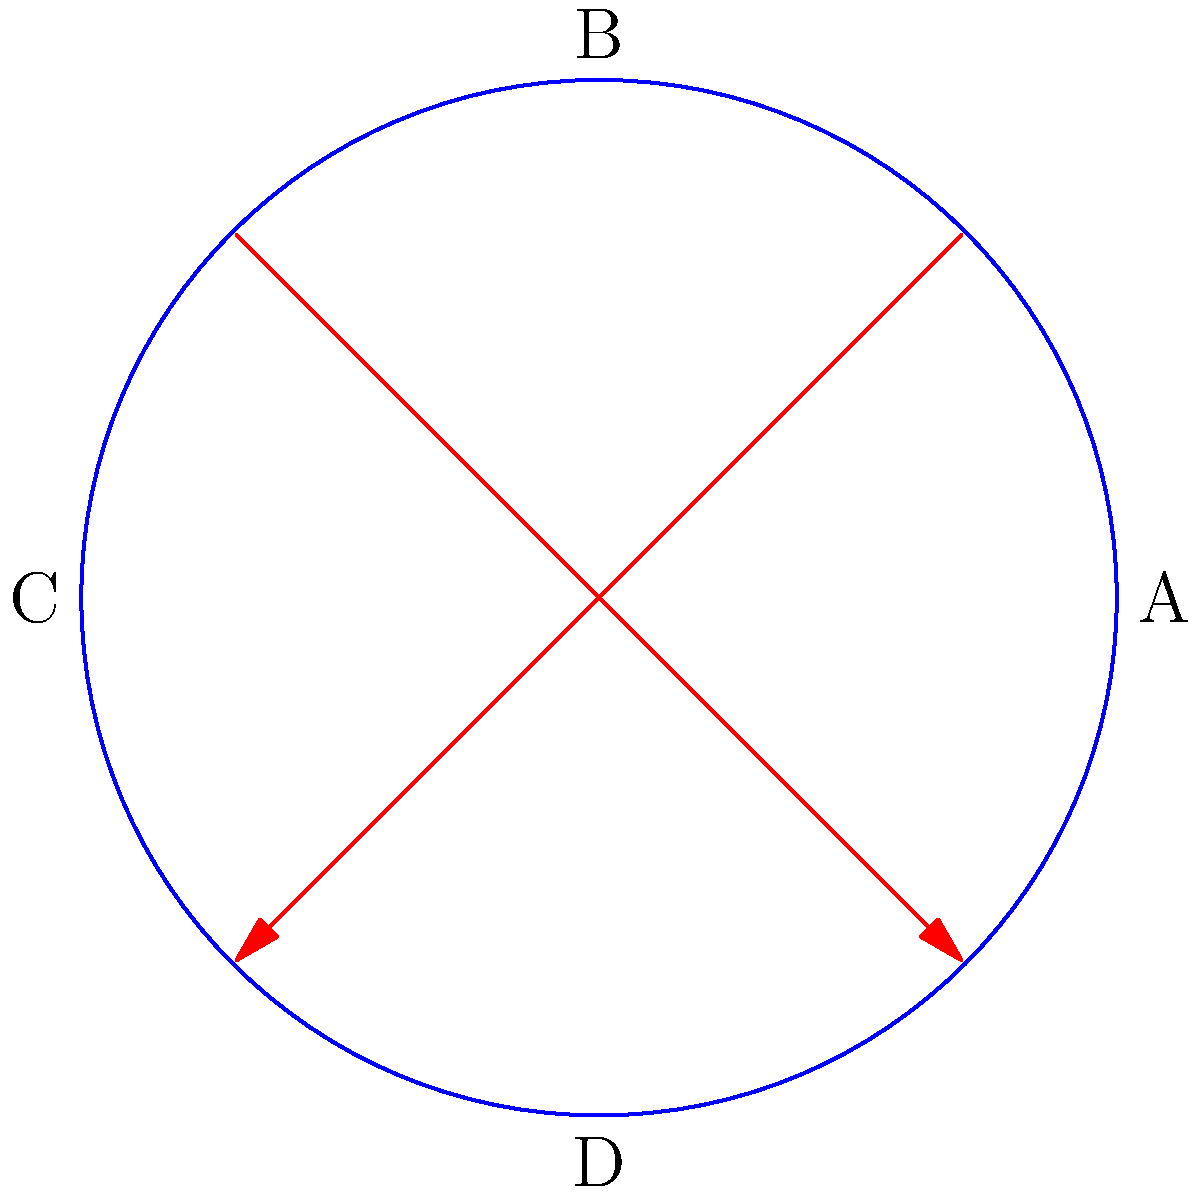As a patrol officer, you're designing a fair rotation system for four officers (A, B, C, D) across four shifts. The diagram represents a permutation in the rotation system. If this permutation is applied twice, what is the resulting arrangement of officers? Let's approach this step-by-step:

1) First, we need to understand what the diagram represents. The arrows show that:
   A swaps with C
   B swaps with D

2) This can be written in cycle notation as (AC)(BD).

3) Now, we need to apply this permutation twice. Let's see what happens:
   - Starting with ABCD
   - After first application: CBAD
   - After second application: ABCD

4) To understand why:
   - A goes to C, then C goes back to A
   - B goes to D, then D goes back to B
   - C goes to A, then A goes back to C
   - D goes to B, then B goes back to D

5) In group theory, this is an example of an involution - a function that is its own inverse. When applied twice, it returns to the original state.

6) Therefore, applying this permutation twice results in the identity permutation, returning all officers to their original positions.
Answer: ABCD 